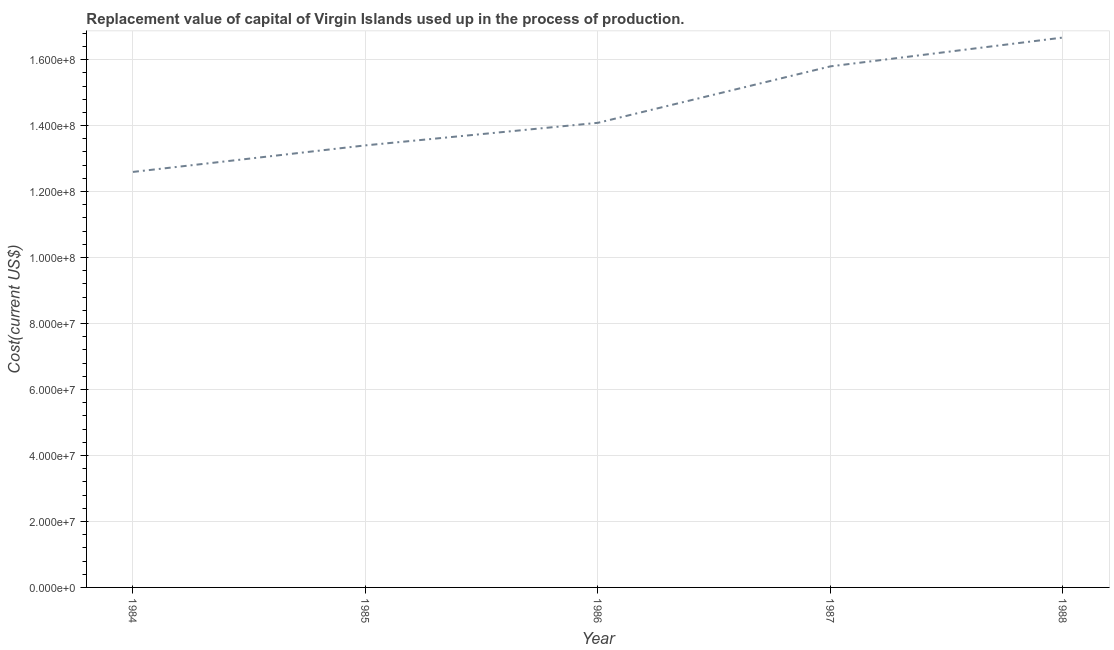What is the consumption of fixed capital in 1984?
Provide a succinct answer. 1.26e+08. Across all years, what is the maximum consumption of fixed capital?
Provide a short and direct response. 1.67e+08. Across all years, what is the minimum consumption of fixed capital?
Make the answer very short. 1.26e+08. In which year was the consumption of fixed capital minimum?
Your response must be concise. 1984. What is the sum of the consumption of fixed capital?
Keep it short and to the point. 7.25e+08. What is the difference between the consumption of fixed capital in 1984 and 1986?
Offer a very short reply. -1.49e+07. What is the average consumption of fixed capital per year?
Make the answer very short. 1.45e+08. What is the median consumption of fixed capital?
Give a very brief answer. 1.41e+08. Do a majority of the years between 1985 and 1988 (inclusive) have consumption of fixed capital greater than 60000000 US$?
Make the answer very short. Yes. What is the ratio of the consumption of fixed capital in 1984 to that in 1986?
Offer a very short reply. 0.89. Is the consumption of fixed capital in 1985 less than that in 1987?
Your response must be concise. Yes. What is the difference between the highest and the second highest consumption of fixed capital?
Your response must be concise. 8.73e+06. What is the difference between the highest and the lowest consumption of fixed capital?
Ensure brevity in your answer.  4.07e+07. In how many years, is the consumption of fixed capital greater than the average consumption of fixed capital taken over all years?
Offer a terse response. 2. What is the difference between two consecutive major ticks on the Y-axis?
Provide a succinct answer. 2.00e+07. Are the values on the major ticks of Y-axis written in scientific E-notation?
Your answer should be compact. Yes. What is the title of the graph?
Your answer should be very brief. Replacement value of capital of Virgin Islands used up in the process of production. What is the label or title of the Y-axis?
Keep it short and to the point. Cost(current US$). What is the Cost(current US$) of 1984?
Your response must be concise. 1.26e+08. What is the Cost(current US$) of 1985?
Your response must be concise. 1.34e+08. What is the Cost(current US$) in 1986?
Give a very brief answer. 1.41e+08. What is the Cost(current US$) in 1987?
Offer a very short reply. 1.58e+08. What is the Cost(current US$) in 1988?
Your response must be concise. 1.67e+08. What is the difference between the Cost(current US$) in 1984 and 1985?
Your answer should be compact. -8.05e+06. What is the difference between the Cost(current US$) in 1984 and 1986?
Your response must be concise. -1.49e+07. What is the difference between the Cost(current US$) in 1984 and 1987?
Make the answer very short. -3.20e+07. What is the difference between the Cost(current US$) in 1984 and 1988?
Your answer should be compact. -4.07e+07. What is the difference between the Cost(current US$) in 1985 and 1986?
Give a very brief answer. -6.84e+06. What is the difference between the Cost(current US$) in 1985 and 1987?
Keep it short and to the point. -2.40e+07. What is the difference between the Cost(current US$) in 1985 and 1988?
Offer a very short reply. -3.27e+07. What is the difference between the Cost(current US$) in 1986 and 1987?
Your answer should be compact. -1.71e+07. What is the difference between the Cost(current US$) in 1986 and 1988?
Ensure brevity in your answer.  -2.58e+07. What is the difference between the Cost(current US$) in 1987 and 1988?
Keep it short and to the point. -8.73e+06. What is the ratio of the Cost(current US$) in 1984 to that in 1986?
Give a very brief answer. 0.89. What is the ratio of the Cost(current US$) in 1984 to that in 1987?
Your answer should be very brief. 0.8. What is the ratio of the Cost(current US$) in 1984 to that in 1988?
Your response must be concise. 0.76. What is the ratio of the Cost(current US$) in 1985 to that in 1986?
Offer a very short reply. 0.95. What is the ratio of the Cost(current US$) in 1985 to that in 1987?
Your answer should be compact. 0.85. What is the ratio of the Cost(current US$) in 1985 to that in 1988?
Offer a very short reply. 0.8. What is the ratio of the Cost(current US$) in 1986 to that in 1987?
Keep it short and to the point. 0.89. What is the ratio of the Cost(current US$) in 1986 to that in 1988?
Ensure brevity in your answer.  0.84. What is the ratio of the Cost(current US$) in 1987 to that in 1988?
Give a very brief answer. 0.95. 